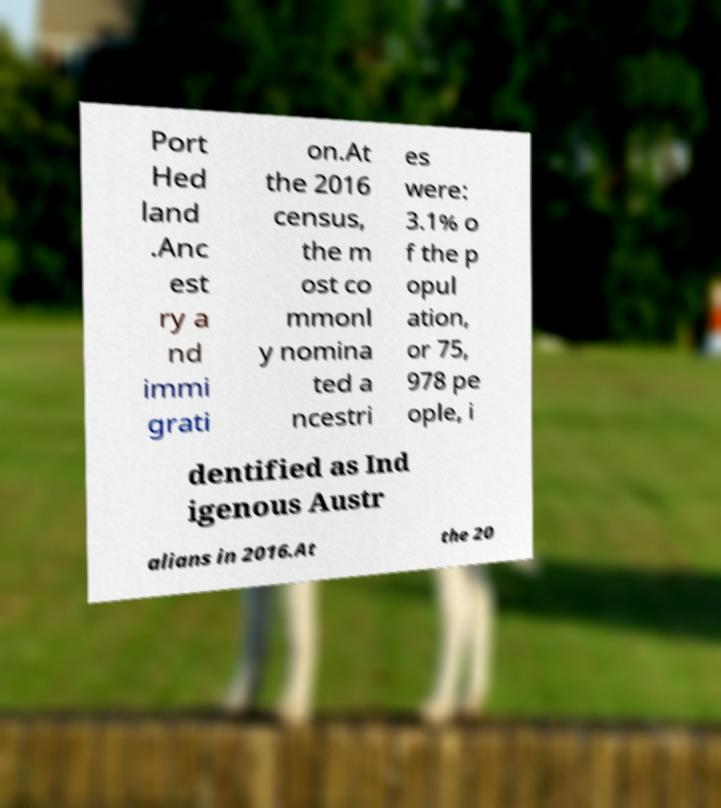There's text embedded in this image that I need extracted. Can you transcribe it verbatim? Port Hed land .Anc est ry a nd immi grati on.At the 2016 census, the m ost co mmonl y nomina ted a ncestri es were: 3.1% o f the p opul ation, or 75, 978 pe ople, i dentified as Ind igenous Austr alians in 2016.At the 20 